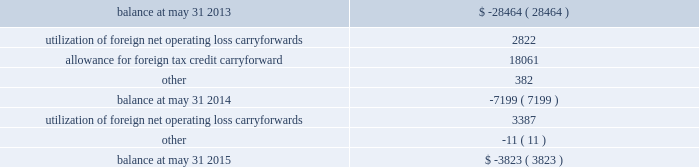Undistributed earnings of $ 696.9 million from certain foreign subsidiaries are considered to be permanently reinvested abroad and will not be repatriated to the united states in the foreseeable future .
Because those earnings are considered to be indefinitely reinvested , no domestic federal or state deferred income taxes have been provided thereon .
If we were to make a distribution of any portion of those earnings in the form of dividends or otherwise , we would be subject to both u.s .
Income taxes ( subject to an adjustment for foreign tax credits ) and withholding taxes payable to the various foreign jurisdictions .
Because of the availability of u.s .
Foreign tax credit carryforwards , it is not practicable to determine the domestic federal income tax liability that would be payable if such earnings were no longer considered to be reinvested indefinitely .
A valuation allowance is provided against deferred tax assets when it is more likely than not that some portion or all of the deferred tax assets will not be realized .
Changes to our valuation allowance during the years ended may 31 , 2015 and 2014 are summarized below ( in thousands ) : .
Net operating loss carryforwards of foreign subsidiaries totaling $ 12.4 million and u.s .
Net operating loss carryforwards previously acquired totaling $ 19.8 million at may 31 , 2015 will expire between may 31 , 2017 and may 31 , 2033 if not utilized .
Capital loss carryforwards of u.s .
Subsidiaries totaling $ 4.7 million will expire if not utilized by may 31 , 2017 .
Tax credit carryforwards totaling $ 8.4 million at may 31 , 2015 will expire between may 31 , 2017 and may 31 , 2023 if not utilized .
We conduct business globally and file income tax returns in the u.s .
Federal jurisdiction and various state and foreign jurisdictions .
In the normal course of business , we are subject to examination by taxing authorities around the world .
As a result of events that occurred in the fourth quarter of the year ended may 31 , 2015 , management concluded that it was more likely than not that the tax positions in a foreign jurisdiction , for which we had recorded estimated liabilities of $ 65.6 million in other noncurrent liabilities on our consolidated balance sheet , would be sustained on their technical merits based on information available as of may 31 , 2015 .
Therefore , the liability and corresponding deferred tax assets were eliminated as of may 31 , 2015 .
The uncertain tax positions have been subject to an ongoing examination in that foreign jurisdiction by the tax authority .
Discussions and correspondence between the tax authority and us during the fourth quarter indicated that the likelihood of the positions being sustained had increased .
Subsequent to may 31 , 2015 , we received a final closure notice regarding the examination resulting in no adjustments to taxable income related to this matter for the tax returns filed for the periods ended may 31 , 2010 through may 31 , 2013 .
The unrecognized tax benefits were effectively settled with this final closure notice .
We are no longer subjected to state income tax examinations for years ended on or before may 31 , 2008 , u.s .
Federal income tax examinations for fiscal years prior to 2012 and united kingdom federal income tax examinations for years ended on or before may 31 , 2013 .
78 2013 global payments inc .
| 2015 form 10-k annual report .
How much has the balance changed from 2013 to 2015? 
Rationale: to calculate the change in balance from 2013 to 2015 we must subtract the 2013 balance from the 2015 balance ( it is a lot easier if one leaves the two numbers positive ) . this difference if left positive is the increase in the balance .
Computations: (28464 - 3823)
Answer: 24641.0. Undistributed earnings of $ 696.9 million from certain foreign subsidiaries are considered to be permanently reinvested abroad and will not be repatriated to the united states in the foreseeable future .
Because those earnings are considered to be indefinitely reinvested , no domestic federal or state deferred income taxes have been provided thereon .
If we were to make a distribution of any portion of those earnings in the form of dividends or otherwise , we would be subject to both u.s .
Income taxes ( subject to an adjustment for foreign tax credits ) and withholding taxes payable to the various foreign jurisdictions .
Because of the availability of u.s .
Foreign tax credit carryforwards , it is not practicable to determine the domestic federal income tax liability that would be payable if such earnings were no longer considered to be reinvested indefinitely .
A valuation allowance is provided against deferred tax assets when it is more likely than not that some portion or all of the deferred tax assets will not be realized .
Changes to our valuation allowance during the years ended may 31 , 2015 and 2014 are summarized below ( in thousands ) : .
Net operating loss carryforwards of foreign subsidiaries totaling $ 12.4 million and u.s .
Net operating loss carryforwards previously acquired totaling $ 19.8 million at may 31 , 2015 will expire between may 31 , 2017 and may 31 , 2033 if not utilized .
Capital loss carryforwards of u.s .
Subsidiaries totaling $ 4.7 million will expire if not utilized by may 31 , 2017 .
Tax credit carryforwards totaling $ 8.4 million at may 31 , 2015 will expire between may 31 , 2017 and may 31 , 2023 if not utilized .
We conduct business globally and file income tax returns in the u.s .
Federal jurisdiction and various state and foreign jurisdictions .
In the normal course of business , we are subject to examination by taxing authorities around the world .
As a result of events that occurred in the fourth quarter of the year ended may 31 , 2015 , management concluded that it was more likely than not that the tax positions in a foreign jurisdiction , for which we had recorded estimated liabilities of $ 65.6 million in other noncurrent liabilities on our consolidated balance sheet , would be sustained on their technical merits based on information available as of may 31 , 2015 .
Therefore , the liability and corresponding deferred tax assets were eliminated as of may 31 , 2015 .
The uncertain tax positions have been subject to an ongoing examination in that foreign jurisdiction by the tax authority .
Discussions and correspondence between the tax authority and us during the fourth quarter indicated that the likelihood of the positions being sustained had increased .
Subsequent to may 31 , 2015 , we received a final closure notice regarding the examination resulting in no adjustments to taxable income related to this matter for the tax returns filed for the periods ended may 31 , 2010 through may 31 , 2013 .
The unrecognized tax benefits were effectively settled with this final closure notice .
We are no longer subjected to state income tax examinations for years ended on or before may 31 , 2008 , u.s .
Federal income tax examinations for fiscal years prior to 2012 and united kingdom federal income tax examinations for years ended on or before may 31 , 2013 .
78 2013 global payments inc .
| 2015 form 10-k annual report .
What is the net change in the balance of valuation allowance during 2015? 
Computations: (3387 + -11)
Answer: 3376.0. 